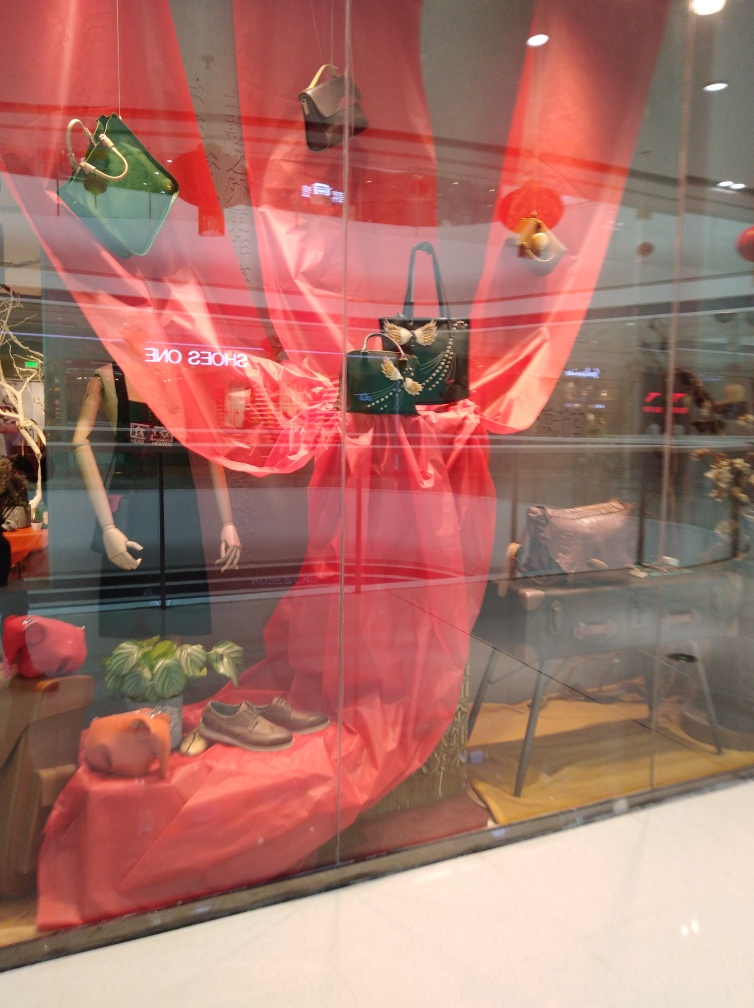Is the reflection on the glass of the display window quite noticeable? Yes, the reflection on the glass is somewhat noticeable, subtly overlaying the display window's content which includes various handbags, a pair of shoes and other accessories set against a vibrant red backdrop. The reflection adds a layer of visual complexity to the scene but doesn't completely obscure the items on display. 